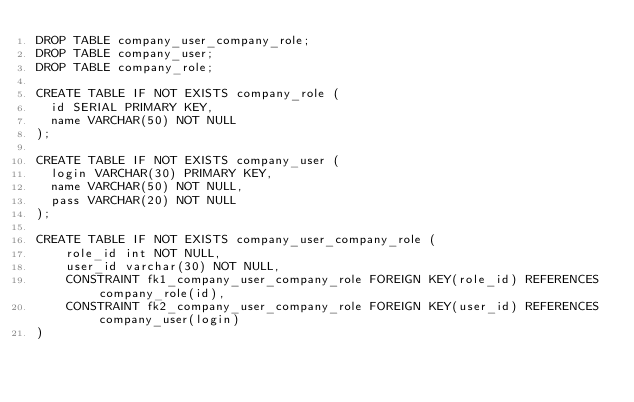Convert code to text. <code><loc_0><loc_0><loc_500><loc_500><_SQL_>DROP TABLE company_user_company_role;
DROP TABLE company_user;
DROP TABLE company_role;

CREATE TABLE IF NOT EXISTS company_role (
	id SERIAL PRIMARY KEY,
	name VARCHAR(50) NOT NULL
);

CREATE TABLE IF NOT EXISTS company_user (
	login VARCHAR(30) PRIMARY KEY,
	name VARCHAR(50) NOT NULL,
	pass VARCHAR(20) NOT NULL
);

CREATE TABLE IF NOT EXISTS company_user_company_role (
    role_id int NOT NULL,
    user_id varchar(30) NOT NULL,
    CONSTRAINT fk1_company_user_company_role FOREIGN KEY(role_id) REFERENCES company_role(id),
    CONSTRAINT fk2_company_user_company_role FOREIGN KEY(user_id) REFERENCES company_user(login)
)</code> 